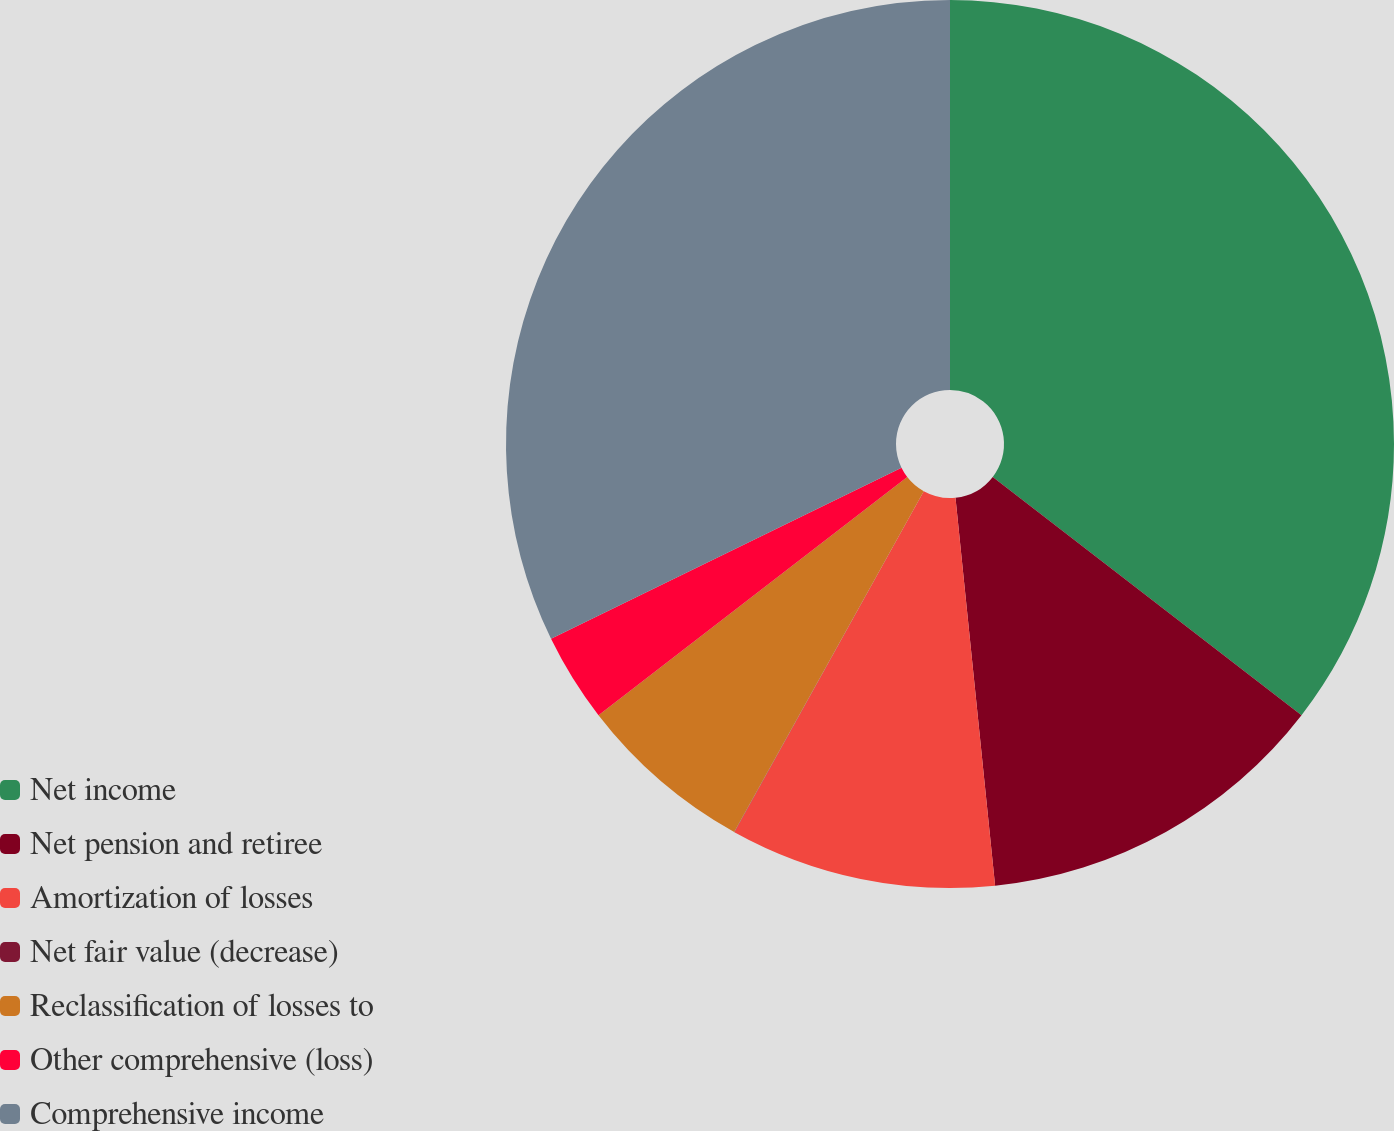Convert chart. <chart><loc_0><loc_0><loc_500><loc_500><pie_chart><fcel>Net income<fcel>Net pension and retiree<fcel>Amortization of losses<fcel>Net fair value (decrease)<fcel>Reclassification of losses to<fcel>Other comprehensive (loss)<fcel>Comprehensive income<nl><fcel>35.46%<fcel>12.92%<fcel>9.69%<fcel>0.01%<fcel>6.46%<fcel>3.23%<fcel>32.23%<nl></chart> 